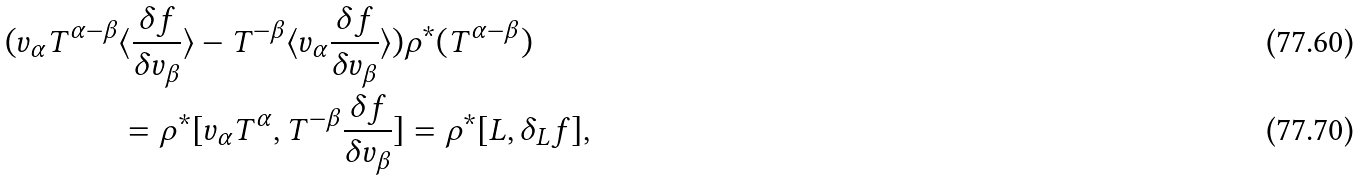Convert formula to latex. <formula><loc_0><loc_0><loc_500><loc_500>( v _ { \alpha } T ^ { \alpha - \beta } & \langle \frac { \delta f } { \delta v _ { \beta } } \rangle - T ^ { - \beta } \langle v _ { \alpha } \frac { \delta f } { \delta v _ { \beta } } \rangle ) \rho ^ { * } ( T ^ { \alpha - \beta } ) \\ & = \rho ^ { * } [ v _ { \alpha } T ^ { \alpha } , T ^ { - \beta } \frac { \delta f } { \delta v _ { \beta } } ] = \rho ^ { * } [ L , \delta _ { L } f ] ,</formula> 